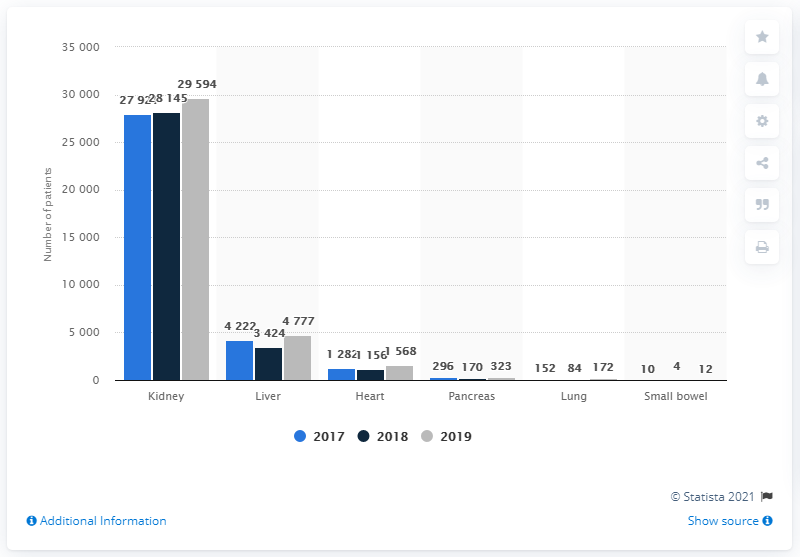Draw attention to some important aspects in this diagram. In 2019, there were approximately 29,594 patients on the kidney transplant waiting list in Turkey. 